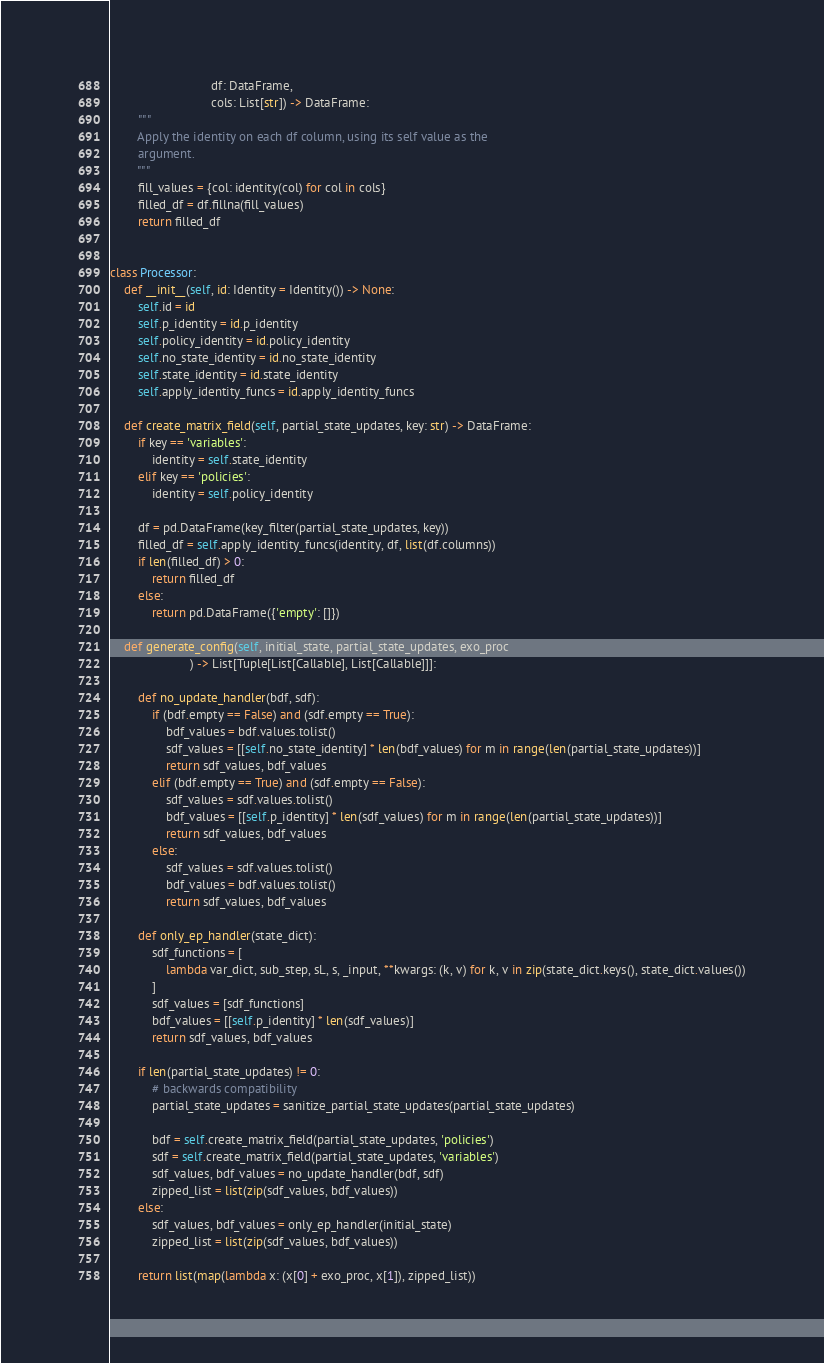Convert code to text. <code><loc_0><loc_0><loc_500><loc_500><_Python_>                             df: DataFrame,
                             cols: List[str]) -> DataFrame:
        """
        Apply the identity on each df column, using its self value as the
        argument.
        """
        fill_values = {col: identity(col) for col in cols}
        filled_df = df.fillna(fill_values)
        return filled_df


class Processor:
    def __init__(self, id: Identity = Identity()) -> None:
        self.id = id
        self.p_identity = id.p_identity
        self.policy_identity = id.policy_identity
        self.no_state_identity = id.no_state_identity
        self.state_identity = id.state_identity
        self.apply_identity_funcs = id.apply_identity_funcs

    def create_matrix_field(self, partial_state_updates, key: str) -> DataFrame:
        if key == 'variables':
            identity = self.state_identity
        elif key == 'policies':
            identity = self.policy_identity

        df = pd.DataFrame(key_filter(partial_state_updates, key))
        filled_df = self.apply_identity_funcs(identity, df, list(df.columns))
        if len(filled_df) > 0:
            return filled_df
        else:
            return pd.DataFrame({'empty': []})

    def generate_config(self, initial_state, partial_state_updates, exo_proc
                       ) -> List[Tuple[List[Callable], List[Callable]]]:

        def no_update_handler(bdf, sdf):
            if (bdf.empty == False) and (sdf.empty == True):
                bdf_values = bdf.values.tolist()
                sdf_values = [[self.no_state_identity] * len(bdf_values) for m in range(len(partial_state_updates))]
                return sdf_values, bdf_values
            elif (bdf.empty == True) and (sdf.empty == False):
                sdf_values = sdf.values.tolist()
                bdf_values = [[self.p_identity] * len(sdf_values) for m in range(len(partial_state_updates))]
                return sdf_values, bdf_values
            else:
                sdf_values = sdf.values.tolist()
                bdf_values = bdf.values.tolist()
                return sdf_values, bdf_values

        def only_ep_handler(state_dict):
            sdf_functions = [
                lambda var_dict, sub_step, sL, s, _input, **kwargs: (k, v) for k, v in zip(state_dict.keys(), state_dict.values())
            ]
            sdf_values = [sdf_functions]
            bdf_values = [[self.p_identity] * len(sdf_values)]
            return sdf_values, bdf_values

        if len(partial_state_updates) != 0:
            # backwards compatibility
            partial_state_updates = sanitize_partial_state_updates(partial_state_updates)

            bdf = self.create_matrix_field(partial_state_updates, 'policies')
            sdf = self.create_matrix_field(partial_state_updates, 'variables')
            sdf_values, bdf_values = no_update_handler(bdf, sdf)
            zipped_list = list(zip(sdf_values, bdf_values))
        else:
            sdf_values, bdf_values = only_ep_handler(initial_state)
            zipped_list = list(zip(sdf_values, bdf_values))

        return list(map(lambda x: (x[0] + exo_proc, x[1]), zipped_list))
</code> 